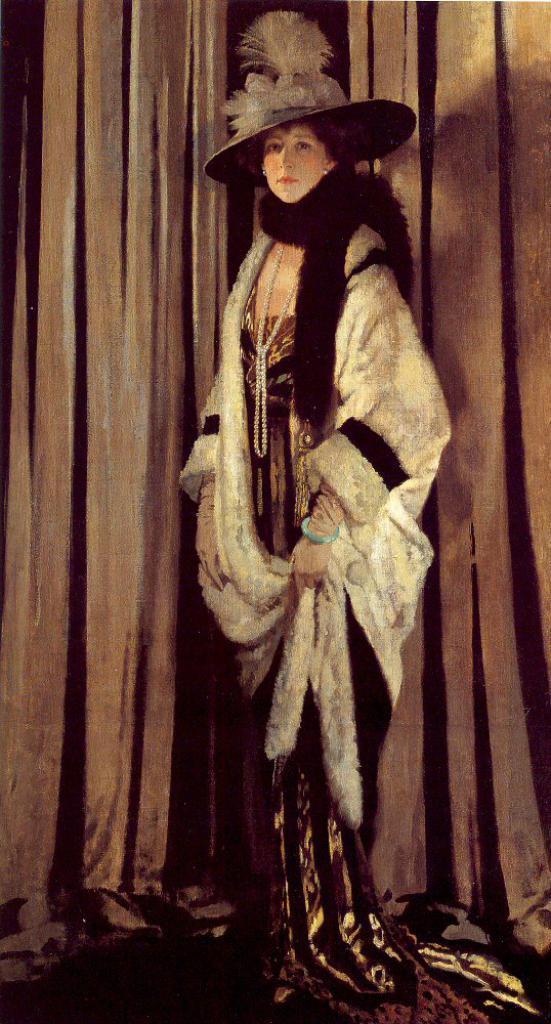Please provide a concise description of this image. In the center of the image, we can see a lady wearing costume and in the background, there is a curtain. 